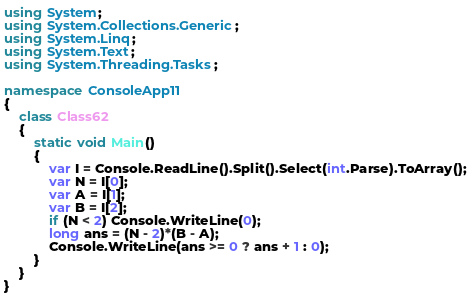<code> <loc_0><loc_0><loc_500><loc_500><_C#_>using System;
using System.Collections.Generic;
using System.Linq;
using System.Text;
using System.Threading.Tasks;

namespace ConsoleApp11
{
    class Class62
    {
        static void Main()
        {
            var I = Console.ReadLine().Split().Select(int.Parse).ToArray();
            var N = I[0];
            var A = I[1];
            var B = I[2];
            if (N < 2) Console.WriteLine(0);
            long ans = (N - 2)*(B - A);
            Console.WriteLine(ans >= 0 ? ans + 1 : 0);
        }
    }
}
</code> 